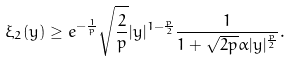Convert formula to latex. <formula><loc_0><loc_0><loc_500><loc_500>\xi _ { 2 } ( y ) \geq e ^ { - \frac { 1 } { p } } \sqrt { \frac { 2 } { p } } | y | ^ { 1 - \frac { p } { 2 } } \frac { 1 } { 1 + \sqrt { 2 p } \alpha | y | ^ { \frac { p } { 2 } } } .</formula> 